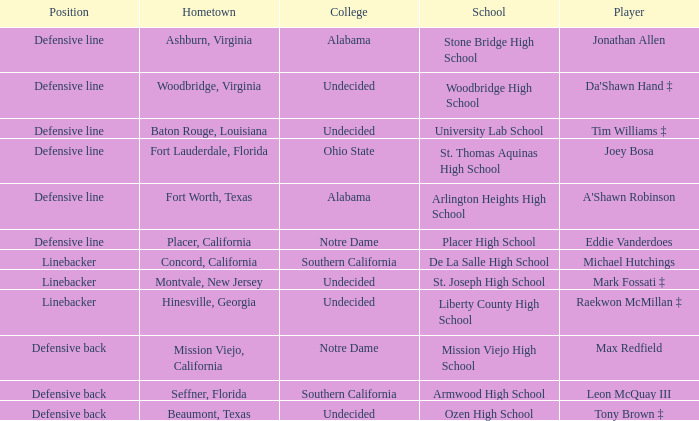What position did Max Redfield play? Defensive back. 